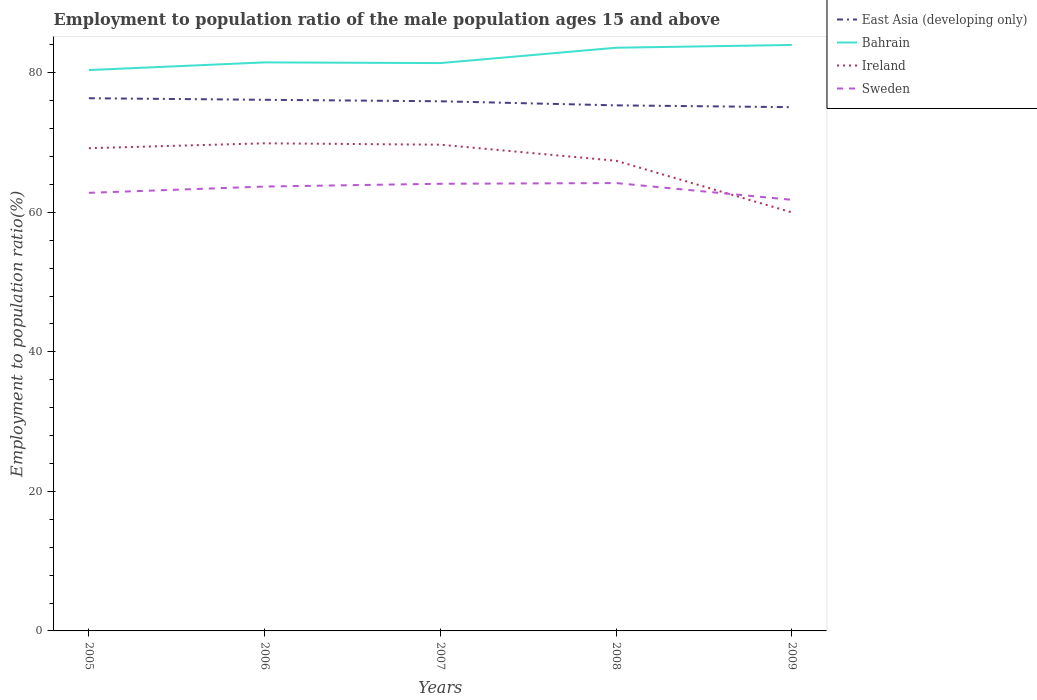Is the number of lines equal to the number of legend labels?
Give a very brief answer. Yes. Across all years, what is the maximum employment to population ratio in Sweden?
Your response must be concise. 61.8. What is the total employment to population ratio in Bahrain in the graph?
Your answer should be compact. -1. What is the difference between the highest and the second highest employment to population ratio in Sweden?
Provide a short and direct response. 2.4. What is the difference between the highest and the lowest employment to population ratio in Bahrain?
Your answer should be compact. 2. How many years are there in the graph?
Offer a terse response. 5. What is the difference between two consecutive major ticks on the Y-axis?
Your answer should be compact. 20. Are the values on the major ticks of Y-axis written in scientific E-notation?
Keep it short and to the point. No. Does the graph contain any zero values?
Your answer should be very brief. No. Does the graph contain grids?
Offer a very short reply. No. Where does the legend appear in the graph?
Make the answer very short. Top right. How are the legend labels stacked?
Provide a short and direct response. Vertical. What is the title of the graph?
Your response must be concise. Employment to population ratio of the male population ages 15 and above. Does "South Sudan" appear as one of the legend labels in the graph?
Provide a succinct answer. No. What is the label or title of the X-axis?
Provide a short and direct response. Years. What is the label or title of the Y-axis?
Offer a terse response. Employment to population ratio(%). What is the Employment to population ratio(%) of East Asia (developing only) in 2005?
Offer a terse response. 76.36. What is the Employment to population ratio(%) in Bahrain in 2005?
Offer a very short reply. 80.4. What is the Employment to population ratio(%) in Ireland in 2005?
Offer a very short reply. 69.2. What is the Employment to population ratio(%) in Sweden in 2005?
Make the answer very short. 62.8. What is the Employment to population ratio(%) of East Asia (developing only) in 2006?
Make the answer very short. 76.14. What is the Employment to population ratio(%) of Bahrain in 2006?
Provide a succinct answer. 81.5. What is the Employment to population ratio(%) of Ireland in 2006?
Your answer should be very brief. 69.9. What is the Employment to population ratio(%) in Sweden in 2006?
Your answer should be compact. 63.7. What is the Employment to population ratio(%) in East Asia (developing only) in 2007?
Your answer should be compact. 75.93. What is the Employment to population ratio(%) of Bahrain in 2007?
Make the answer very short. 81.4. What is the Employment to population ratio(%) of Ireland in 2007?
Offer a very short reply. 69.7. What is the Employment to population ratio(%) of Sweden in 2007?
Offer a very short reply. 64.1. What is the Employment to population ratio(%) in East Asia (developing only) in 2008?
Ensure brevity in your answer.  75.34. What is the Employment to population ratio(%) of Bahrain in 2008?
Offer a very short reply. 83.6. What is the Employment to population ratio(%) in Ireland in 2008?
Provide a succinct answer. 67.4. What is the Employment to population ratio(%) of Sweden in 2008?
Offer a very short reply. 64.2. What is the Employment to population ratio(%) of East Asia (developing only) in 2009?
Offer a very short reply. 75.08. What is the Employment to population ratio(%) in Bahrain in 2009?
Keep it short and to the point. 84. What is the Employment to population ratio(%) in Ireland in 2009?
Make the answer very short. 60. What is the Employment to population ratio(%) of Sweden in 2009?
Ensure brevity in your answer.  61.8. Across all years, what is the maximum Employment to population ratio(%) of East Asia (developing only)?
Give a very brief answer. 76.36. Across all years, what is the maximum Employment to population ratio(%) of Bahrain?
Your answer should be very brief. 84. Across all years, what is the maximum Employment to population ratio(%) in Ireland?
Your answer should be compact. 69.9. Across all years, what is the maximum Employment to population ratio(%) of Sweden?
Keep it short and to the point. 64.2. Across all years, what is the minimum Employment to population ratio(%) of East Asia (developing only)?
Give a very brief answer. 75.08. Across all years, what is the minimum Employment to population ratio(%) in Bahrain?
Your response must be concise. 80.4. Across all years, what is the minimum Employment to population ratio(%) in Sweden?
Give a very brief answer. 61.8. What is the total Employment to population ratio(%) of East Asia (developing only) in the graph?
Offer a very short reply. 378.85. What is the total Employment to population ratio(%) of Bahrain in the graph?
Offer a very short reply. 410.9. What is the total Employment to population ratio(%) in Ireland in the graph?
Give a very brief answer. 336.2. What is the total Employment to population ratio(%) of Sweden in the graph?
Your response must be concise. 316.6. What is the difference between the Employment to population ratio(%) of East Asia (developing only) in 2005 and that in 2006?
Offer a terse response. 0.22. What is the difference between the Employment to population ratio(%) in Ireland in 2005 and that in 2006?
Your answer should be compact. -0.7. What is the difference between the Employment to population ratio(%) in Sweden in 2005 and that in 2006?
Provide a succinct answer. -0.9. What is the difference between the Employment to population ratio(%) in East Asia (developing only) in 2005 and that in 2007?
Provide a short and direct response. 0.43. What is the difference between the Employment to population ratio(%) of Bahrain in 2005 and that in 2007?
Provide a short and direct response. -1. What is the difference between the Employment to population ratio(%) of East Asia (developing only) in 2005 and that in 2008?
Your answer should be compact. 1.02. What is the difference between the Employment to population ratio(%) of East Asia (developing only) in 2005 and that in 2009?
Keep it short and to the point. 1.28. What is the difference between the Employment to population ratio(%) in Bahrain in 2005 and that in 2009?
Offer a very short reply. -3.6. What is the difference between the Employment to population ratio(%) of Ireland in 2005 and that in 2009?
Make the answer very short. 9.2. What is the difference between the Employment to population ratio(%) of Sweden in 2005 and that in 2009?
Provide a short and direct response. 1. What is the difference between the Employment to population ratio(%) of East Asia (developing only) in 2006 and that in 2007?
Offer a very short reply. 0.21. What is the difference between the Employment to population ratio(%) of East Asia (developing only) in 2006 and that in 2008?
Offer a very short reply. 0.8. What is the difference between the Employment to population ratio(%) of Bahrain in 2006 and that in 2008?
Keep it short and to the point. -2.1. What is the difference between the Employment to population ratio(%) in Sweden in 2006 and that in 2008?
Provide a short and direct response. -0.5. What is the difference between the Employment to population ratio(%) of East Asia (developing only) in 2006 and that in 2009?
Give a very brief answer. 1.06. What is the difference between the Employment to population ratio(%) of East Asia (developing only) in 2007 and that in 2008?
Your answer should be very brief. 0.59. What is the difference between the Employment to population ratio(%) of Sweden in 2007 and that in 2008?
Ensure brevity in your answer.  -0.1. What is the difference between the Employment to population ratio(%) of East Asia (developing only) in 2007 and that in 2009?
Ensure brevity in your answer.  0.85. What is the difference between the Employment to population ratio(%) in Ireland in 2007 and that in 2009?
Provide a short and direct response. 9.7. What is the difference between the Employment to population ratio(%) in Sweden in 2007 and that in 2009?
Give a very brief answer. 2.3. What is the difference between the Employment to population ratio(%) of East Asia (developing only) in 2008 and that in 2009?
Your answer should be compact. 0.26. What is the difference between the Employment to population ratio(%) in Sweden in 2008 and that in 2009?
Give a very brief answer. 2.4. What is the difference between the Employment to population ratio(%) in East Asia (developing only) in 2005 and the Employment to population ratio(%) in Bahrain in 2006?
Your response must be concise. -5.14. What is the difference between the Employment to population ratio(%) of East Asia (developing only) in 2005 and the Employment to population ratio(%) of Ireland in 2006?
Keep it short and to the point. 6.46. What is the difference between the Employment to population ratio(%) of East Asia (developing only) in 2005 and the Employment to population ratio(%) of Sweden in 2006?
Offer a very short reply. 12.66. What is the difference between the Employment to population ratio(%) in East Asia (developing only) in 2005 and the Employment to population ratio(%) in Bahrain in 2007?
Make the answer very short. -5.04. What is the difference between the Employment to population ratio(%) in East Asia (developing only) in 2005 and the Employment to population ratio(%) in Ireland in 2007?
Keep it short and to the point. 6.66. What is the difference between the Employment to population ratio(%) of East Asia (developing only) in 2005 and the Employment to population ratio(%) of Sweden in 2007?
Your response must be concise. 12.26. What is the difference between the Employment to population ratio(%) of Bahrain in 2005 and the Employment to population ratio(%) of Sweden in 2007?
Keep it short and to the point. 16.3. What is the difference between the Employment to population ratio(%) of East Asia (developing only) in 2005 and the Employment to population ratio(%) of Bahrain in 2008?
Provide a short and direct response. -7.24. What is the difference between the Employment to population ratio(%) in East Asia (developing only) in 2005 and the Employment to population ratio(%) in Ireland in 2008?
Keep it short and to the point. 8.96. What is the difference between the Employment to population ratio(%) in East Asia (developing only) in 2005 and the Employment to population ratio(%) in Sweden in 2008?
Your answer should be compact. 12.16. What is the difference between the Employment to population ratio(%) of Bahrain in 2005 and the Employment to population ratio(%) of Sweden in 2008?
Your answer should be very brief. 16.2. What is the difference between the Employment to population ratio(%) in Ireland in 2005 and the Employment to population ratio(%) in Sweden in 2008?
Give a very brief answer. 5. What is the difference between the Employment to population ratio(%) of East Asia (developing only) in 2005 and the Employment to population ratio(%) of Bahrain in 2009?
Your answer should be very brief. -7.64. What is the difference between the Employment to population ratio(%) in East Asia (developing only) in 2005 and the Employment to population ratio(%) in Ireland in 2009?
Your answer should be very brief. 16.36. What is the difference between the Employment to population ratio(%) of East Asia (developing only) in 2005 and the Employment to population ratio(%) of Sweden in 2009?
Offer a terse response. 14.56. What is the difference between the Employment to population ratio(%) of Bahrain in 2005 and the Employment to population ratio(%) of Ireland in 2009?
Keep it short and to the point. 20.4. What is the difference between the Employment to population ratio(%) in Bahrain in 2005 and the Employment to population ratio(%) in Sweden in 2009?
Offer a terse response. 18.6. What is the difference between the Employment to population ratio(%) of East Asia (developing only) in 2006 and the Employment to population ratio(%) of Bahrain in 2007?
Your answer should be compact. -5.26. What is the difference between the Employment to population ratio(%) of East Asia (developing only) in 2006 and the Employment to population ratio(%) of Ireland in 2007?
Your answer should be compact. 6.44. What is the difference between the Employment to population ratio(%) of East Asia (developing only) in 2006 and the Employment to population ratio(%) of Sweden in 2007?
Make the answer very short. 12.04. What is the difference between the Employment to population ratio(%) of Bahrain in 2006 and the Employment to population ratio(%) of Ireland in 2007?
Give a very brief answer. 11.8. What is the difference between the Employment to population ratio(%) of East Asia (developing only) in 2006 and the Employment to population ratio(%) of Bahrain in 2008?
Your answer should be compact. -7.46. What is the difference between the Employment to population ratio(%) in East Asia (developing only) in 2006 and the Employment to population ratio(%) in Ireland in 2008?
Give a very brief answer. 8.74. What is the difference between the Employment to population ratio(%) of East Asia (developing only) in 2006 and the Employment to population ratio(%) of Sweden in 2008?
Your answer should be very brief. 11.94. What is the difference between the Employment to population ratio(%) in Bahrain in 2006 and the Employment to population ratio(%) in Ireland in 2008?
Give a very brief answer. 14.1. What is the difference between the Employment to population ratio(%) of Bahrain in 2006 and the Employment to population ratio(%) of Sweden in 2008?
Your response must be concise. 17.3. What is the difference between the Employment to population ratio(%) in Ireland in 2006 and the Employment to population ratio(%) in Sweden in 2008?
Provide a succinct answer. 5.7. What is the difference between the Employment to population ratio(%) in East Asia (developing only) in 2006 and the Employment to population ratio(%) in Bahrain in 2009?
Your answer should be compact. -7.86. What is the difference between the Employment to population ratio(%) of East Asia (developing only) in 2006 and the Employment to population ratio(%) of Ireland in 2009?
Your answer should be compact. 16.14. What is the difference between the Employment to population ratio(%) of East Asia (developing only) in 2006 and the Employment to population ratio(%) of Sweden in 2009?
Provide a succinct answer. 14.34. What is the difference between the Employment to population ratio(%) of Bahrain in 2006 and the Employment to population ratio(%) of Sweden in 2009?
Offer a very short reply. 19.7. What is the difference between the Employment to population ratio(%) of Ireland in 2006 and the Employment to population ratio(%) of Sweden in 2009?
Give a very brief answer. 8.1. What is the difference between the Employment to population ratio(%) in East Asia (developing only) in 2007 and the Employment to population ratio(%) in Bahrain in 2008?
Provide a succinct answer. -7.67. What is the difference between the Employment to population ratio(%) of East Asia (developing only) in 2007 and the Employment to population ratio(%) of Ireland in 2008?
Offer a very short reply. 8.53. What is the difference between the Employment to population ratio(%) in East Asia (developing only) in 2007 and the Employment to population ratio(%) in Sweden in 2008?
Offer a very short reply. 11.73. What is the difference between the Employment to population ratio(%) of Bahrain in 2007 and the Employment to population ratio(%) of Ireland in 2008?
Provide a succinct answer. 14. What is the difference between the Employment to population ratio(%) of Bahrain in 2007 and the Employment to population ratio(%) of Sweden in 2008?
Provide a succinct answer. 17.2. What is the difference between the Employment to population ratio(%) of Ireland in 2007 and the Employment to population ratio(%) of Sweden in 2008?
Give a very brief answer. 5.5. What is the difference between the Employment to population ratio(%) in East Asia (developing only) in 2007 and the Employment to population ratio(%) in Bahrain in 2009?
Provide a succinct answer. -8.07. What is the difference between the Employment to population ratio(%) of East Asia (developing only) in 2007 and the Employment to population ratio(%) of Ireland in 2009?
Your answer should be compact. 15.93. What is the difference between the Employment to population ratio(%) of East Asia (developing only) in 2007 and the Employment to population ratio(%) of Sweden in 2009?
Provide a succinct answer. 14.13. What is the difference between the Employment to population ratio(%) of Bahrain in 2007 and the Employment to population ratio(%) of Ireland in 2009?
Your response must be concise. 21.4. What is the difference between the Employment to population ratio(%) of Bahrain in 2007 and the Employment to population ratio(%) of Sweden in 2009?
Ensure brevity in your answer.  19.6. What is the difference between the Employment to population ratio(%) in Ireland in 2007 and the Employment to population ratio(%) in Sweden in 2009?
Offer a terse response. 7.9. What is the difference between the Employment to population ratio(%) in East Asia (developing only) in 2008 and the Employment to population ratio(%) in Bahrain in 2009?
Your answer should be very brief. -8.66. What is the difference between the Employment to population ratio(%) of East Asia (developing only) in 2008 and the Employment to population ratio(%) of Ireland in 2009?
Provide a succinct answer. 15.34. What is the difference between the Employment to population ratio(%) in East Asia (developing only) in 2008 and the Employment to population ratio(%) in Sweden in 2009?
Give a very brief answer. 13.54. What is the difference between the Employment to population ratio(%) in Bahrain in 2008 and the Employment to population ratio(%) in Ireland in 2009?
Provide a succinct answer. 23.6. What is the difference between the Employment to population ratio(%) of Bahrain in 2008 and the Employment to population ratio(%) of Sweden in 2009?
Ensure brevity in your answer.  21.8. What is the average Employment to population ratio(%) of East Asia (developing only) per year?
Provide a succinct answer. 75.77. What is the average Employment to population ratio(%) of Bahrain per year?
Give a very brief answer. 82.18. What is the average Employment to population ratio(%) in Ireland per year?
Your answer should be compact. 67.24. What is the average Employment to population ratio(%) in Sweden per year?
Provide a succinct answer. 63.32. In the year 2005, what is the difference between the Employment to population ratio(%) in East Asia (developing only) and Employment to population ratio(%) in Bahrain?
Keep it short and to the point. -4.04. In the year 2005, what is the difference between the Employment to population ratio(%) in East Asia (developing only) and Employment to population ratio(%) in Ireland?
Your response must be concise. 7.16. In the year 2005, what is the difference between the Employment to population ratio(%) in East Asia (developing only) and Employment to population ratio(%) in Sweden?
Make the answer very short. 13.56. In the year 2005, what is the difference between the Employment to population ratio(%) of Ireland and Employment to population ratio(%) of Sweden?
Keep it short and to the point. 6.4. In the year 2006, what is the difference between the Employment to population ratio(%) of East Asia (developing only) and Employment to population ratio(%) of Bahrain?
Offer a very short reply. -5.36. In the year 2006, what is the difference between the Employment to population ratio(%) in East Asia (developing only) and Employment to population ratio(%) in Ireland?
Your answer should be compact. 6.24. In the year 2006, what is the difference between the Employment to population ratio(%) in East Asia (developing only) and Employment to population ratio(%) in Sweden?
Offer a terse response. 12.44. In the year 2006, what is the difference between the Employment to population ratio(%) of Bahrain and Employment to population ratio(%) of Ireland?
Offer a very short reply. 11.6. In the year 2007, what is the difference between the Employment to population ratio(%) of East Asia (developing only) and Employment to population ratio(%) of Bahrain?
Your response must be concise. -5.47. In the year 2007, what is the difference between the Employment to population ratio(%) in East Asia (developing only) and Employment to population ratio(%) in Ireland?
Make the answer very short. 6.23. In the year 2007, what is the difference between the Employment to population ratio(%) in East Asia (developing only) and Employment to population ratio(%) in Sweden?
Your response must be concise. 11.83. In the year 2007, what is the difference between the Employment to population ratio(%) of Bahrain and Employment to population ratio(%) of Ireland?
Ensure brevity in your answer.  11.7. In the year 2007, what is the difference between the Employment to population ratio(%) in Ireland and Employment to population ratio(%) in Sweden?
Your answer should be very brief. 5.6. In the year 2008, what is the difference between the Employment to population ratio(%) of East Asia (developing only) and Employment to population ratio(%) of Bahrain?
Make the answer very short. -8.26. In the year 2008, what is the difference between the Employment to population ratio(%) of East Asia (developing only) and Employment to population ratio(%) of Ireland?
Offer a terse response. 7.94. In the year 2008, what is the difference between the Employment to population ratio(%) in East Asia (developing only) and Employment to population ratio(%) in Sweden?
Offer a terse response. 11.14. In the year 2008, what is the difference between the Employment to population ratio(%) in Bahrain and Employment to population ratio(%) in Ireland?
Give a very brief answer. 16.2. In the year 2009, what is the difference between the Employment to population ratio(%) of East Asia (developing only) and Employment to population ratio(%) of Bahrain?
Ensure brevity in your answer.  -8.92. In the year 2009, what is the difference between the Employment to population ratio(%) of East Asia (developing only) and Employment to population ratio(%) of Ireland?
Offer a terse response. 15.08. In the year 2009, what is the difference between the Employment to population ratio(%) in East Asia (developing only) and Employment to population ratio(%) in Sweden?
Offer a terse response. 13.28. In the year 2009, what is the difference between the Employment to population ratio(%) of Bahrain and Employment to population ratio(%) of Sweden?
Keep it short and to the point. 22.2. In the year 2009, what is the difference between the Employment to population ratio(%) in Ireland and Employment to population ratio(%) in Sweden?
Your answer should be compact. -1.8. What is the ratio of the Employment to population ratio(%) of Bahrain in 2005 to that in 2006?
Your answer should be very brief. 0.99. What is the ratio of the Employment to population ratio(%) in Sweden in 2005 to that in 2006?
Your answer should be compact. 0.99. What is the ratio of the Employment to population ratio(%) of Bahrain in 2005 to that in 2007?
Offer a very short reply. 0.99. What is the ratio of the Employment to population ratio(%) of Ireland in 2005 to that in 2007?
Give a very brief answer. 0.99. What is the ratio of the Employment to population ratio(%) in Sweden in 2005 to that in 2007?
Your answer should be compact. 0.98. What is the ratio of the Employment to population ratio(%) in East Asia (developing only) in 2005 to that in 2008?
Give a very brief answer. 1.01. What is the ratio of the Employment to population ratio(%) in Bahrain in 2005 to that in 2008?
Offer a terse response. 0.96. What is the ratio of the Employment to population ratio(%) of Ireland in 2005 to that in 2008?
Provide a succinct answer. 1.03. What is the ratio of the Employment to population ratio(%) in Sweden in 2005 to that in 2008?
Your response must be concise. 0.98. What is the ratio of the Employment to population ratio(%) of East Asia (developing only) in 2005 to that in 2009?
Your answer should be compact. 1.02. What is the ratio of the Employment to population ratio(%) of Bahrain in 2005 to that in 2009?
Offer a very short reply. 0.96. What is the ratio of the Employment to population ratio(%) of Ireland in 2005 to that in 2009?
Your response must be concise. 1.15. What is the ratio of the Employment to population ratio(%) in Sweden in 2005 to that in 2009?
Your answer should be very brief. 1.02. What is the ratio of the Employment to population ratio(%) of East Asia (developing only) in 2006 to that in 2008?
Provide a succinct answer. 1.01. What is the ratio of the Employment to population ratio(%) in Bahrain in 2006 to that in 2008?
Offer a very short reply. 0.97. What is the ratio of the Employment to population ratio(%) of Ireland in 2006 to that in 2008?
Ensure brevity in your answer.  1.04. What is the ratio of the Employment to population ratio(%) of Sweden in 2006 to that in 2008?
Ensure brevity in your answer.  0.99. What is the ratio of the Employment to population ratio(%) of East Asia (developing only) in 2006 to that in 2009?
Your answer should be very brief. 1.01. What is the ratio of the Employment to population ratio(%) in Bahrain in 2006 to that in 2009?
Offer a terse response. 0.97. What is the ratio of the Employment to population ratio(%) of Ireland in 2006 to that in 2009?
Your answer should be compact. 1.17. What is the ratio of the Employment to population ratio(%) of Sweden in 2006 to that in 2009?
Offer a terse response. 1.03. What is the ratio of the Employment to population ratio(%) of Bahrain in 2007 to that in 2008?
Your answer should be compact. 0.97. What is the ratio of the Employment to population ratio(%) in Ireland in 2007 to that in 2008?
Provide a succinct answer. 1.03. What is the ratio of the Employment to population ratio(%) of Sweden in 2007 to that in 2008?
Make the answer very short. 1. What is the ratio of the Employment to population ratio(%) of East Asia (developing only) in 2007 to that in 2009?
Keep it short and to the point. 1.01. What is the ratio of the Employment to population ratio(%) of Bahrain in 2007 to that in 2009?
Ensure brevity in your answer.  0.97. What is the ratio of the Employment to population ratio(%) in Ireland in 2007 to that in 2009?
Your answer should be very brief. 1.16. What is the ratio of the Employment to population ratio(%) in Sweden in 2007 to that in 2009?
Keep it short and to the point. 1.04. What is the ratio of the Employment to population ratio(%) of East Asia (developing only) in 2008 to that in 2009?
Offer a very short reply. 1. What is the ratio of the Employment to population ratio(%) of Bahrain in 2008 to that in 2009?
Provide a short and direct response. 1. What is the ratio of the Employment to population ratio(%) in Ireland in 2008 to that in 2009?
Provide a succinct answer. 1.12. What is the ratio of the Employment to population ratio(%) of Sweden in 2008 to that in 2009?
Provide a short and direct response. 1.04. What is the difference between the highest and the second highest Employment to population ratio(%) in East Asia (developing only)?
Offer a terse response. 0.22. What is the difference between the highest and the second highest Employment to population ratio(%) of Bahrain?
Make the answer very short. 0.4. What is the difference between the highest and the lowest Employment to population ratio(%) of East Asia (developing only)?
Your answer should be compact. 1.28. What is the difference between the highest and the lowest Employment to population ratio(%) in Bahrain?
Your response must be concise. 3.6. 